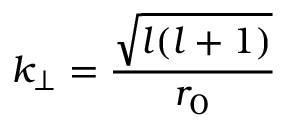Convert formula to latex. <formula><loc_0><loc_0><loc_500><loc_500>k _ { \perp } = \frac { \sqrt { l ( l + 1 ) } } { r _ { 0 } }</formula> 